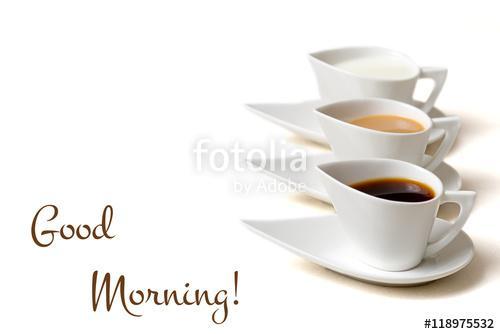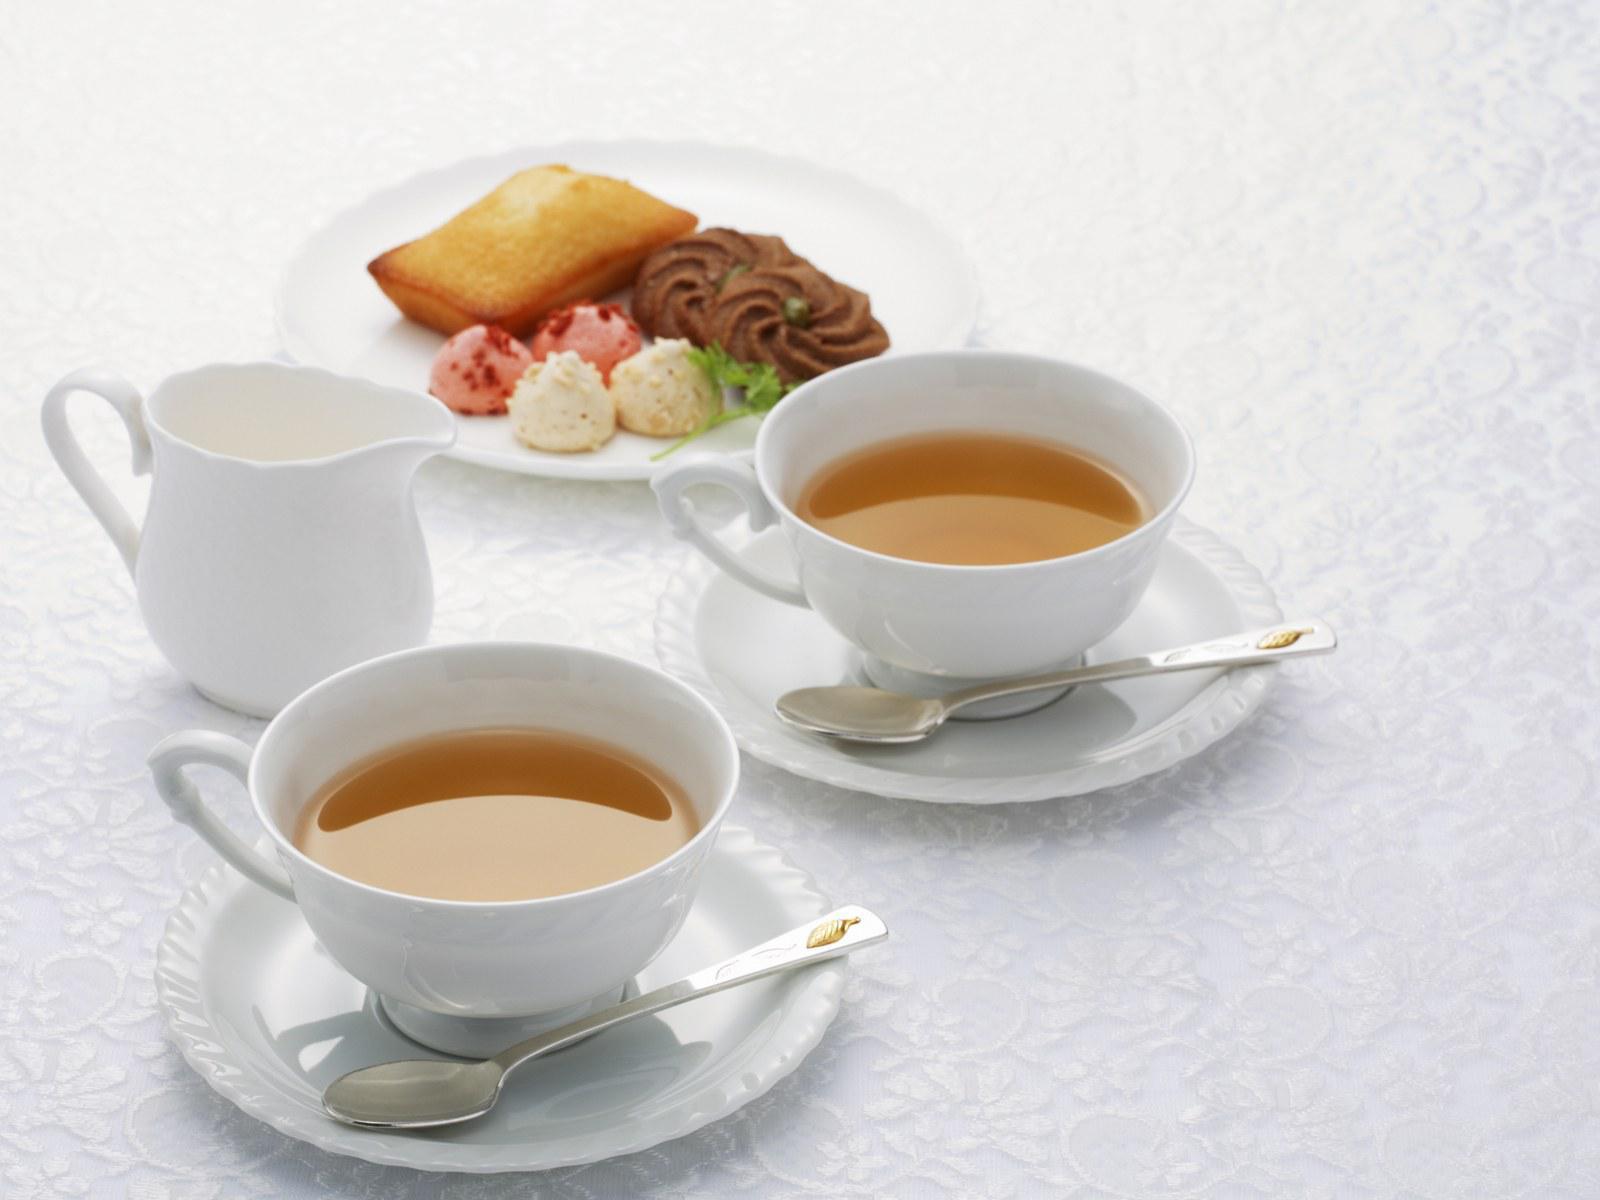The first image is the image on the left, the second image is the image on the right. Evaluate the accuracy of this statement regarding the images: "An image shows a neat row of three matching cups and saucers.". Is it true? Answer yes or no. Yes. The first image is the image on the left, the second image is the image on the right. Assess this claim about the two images: "There are three cups and three saucers in one of the images.". Correct or not? Answer yes or no. Yes. 